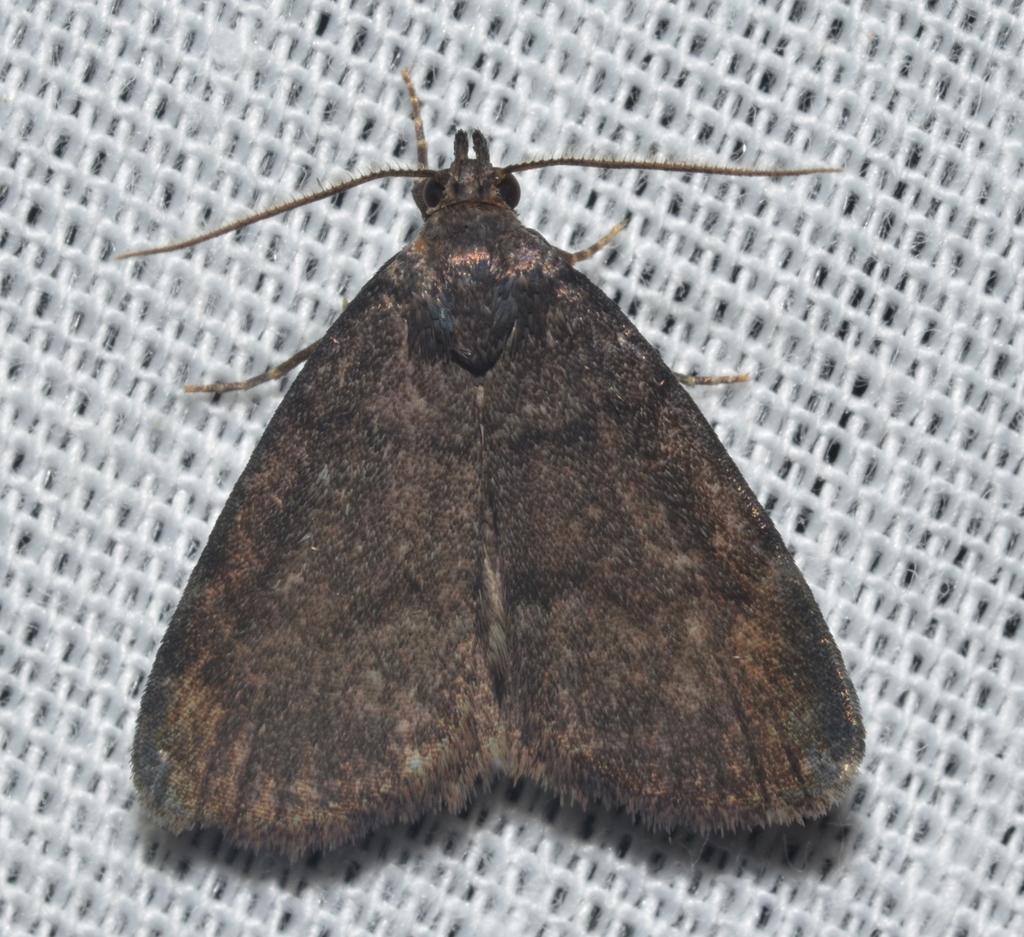How would you summarize this image in a sentence or two? In this image there is a house moth on the path. 